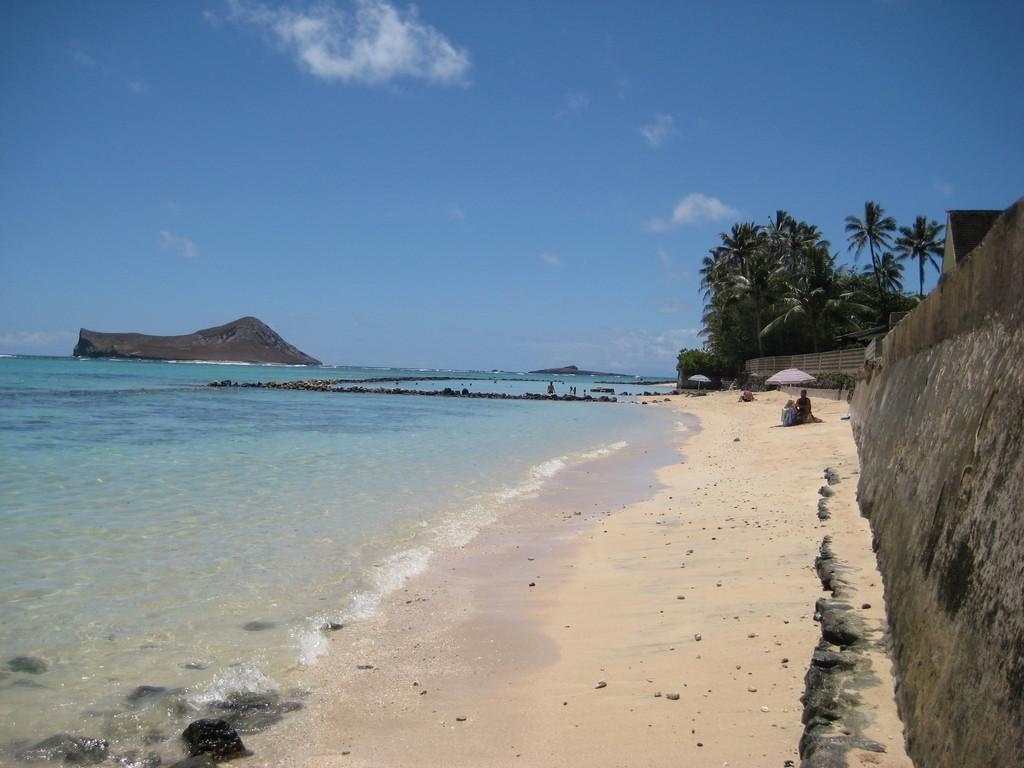What is one of the main elements in the image? There is water in the image. What type of terrain can be seen in the image? There is sand in the image. What structure is present in the image? There is a wall in the image. What type of natural objects are present in the image? There are stones in the image. Can you describe the people in the image? People are visible in the distance. What objects are being used by the people in the distance? Umbrellas are present in the distance. What type of vegetation is visible in the background of the image? There are trees in the background of the image. What type of geological feature is visible in the background of the image? There is a rock in the background of the image. What is visible in the sky in the background of the image? The sky is visible in the background of the image, and clouds are present. How many rabbits are hopping around the rock in the image? There are no rabbits present in the image. What type of lipstick is the woman wearing in the image? There is no woman or lipstick present in the image. 